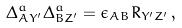Convert formula to latex. <formula><loc_0><loc_0><loc_500><loc_500>\Delta ^ { a } _ { A Y ^ { \prime } } \Delta ^ { a } _ { B Z ^ { \prime } } = \epsilon _ { A B } R _ { Y ^ { \prime } Z ^ { \prime } } \, ,</formula> 